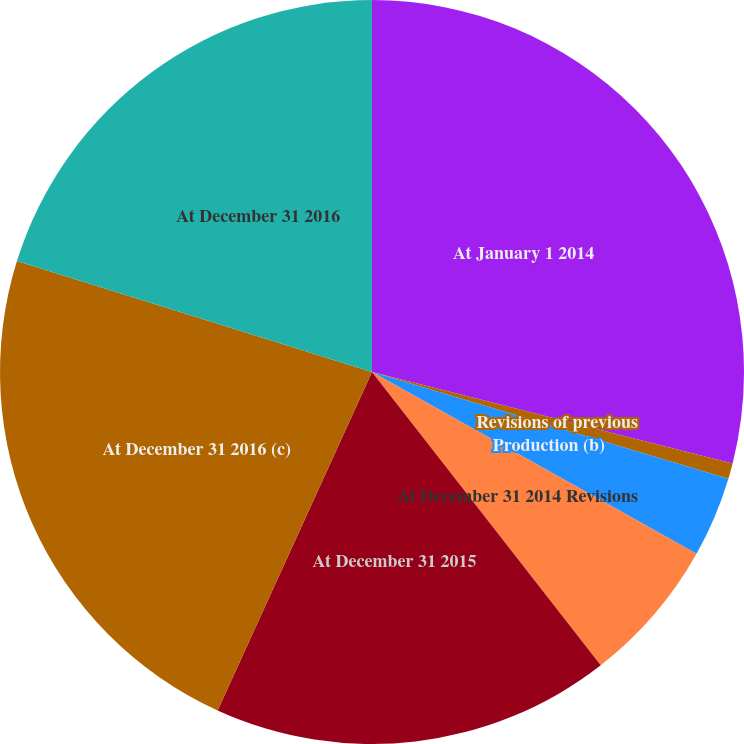<chart> <loc_0><loc_0><loc_500><loc_500><pie_chart><fcel>At January 1 2014<fcel>Revisions of previous<fcel>Production (b)<fcel>At December 31 2014 Revisions<fcel>At December 31 2015<fcel>At December 31 2016 (c)<fcel>At December 31 2016<nl><fcel>28.95%<fcel>0.68%<fcel>3.5%<fcel>6.33%<fcel>17.35%<fcel>23.01%<fcel>20.18%<nl></chart> 